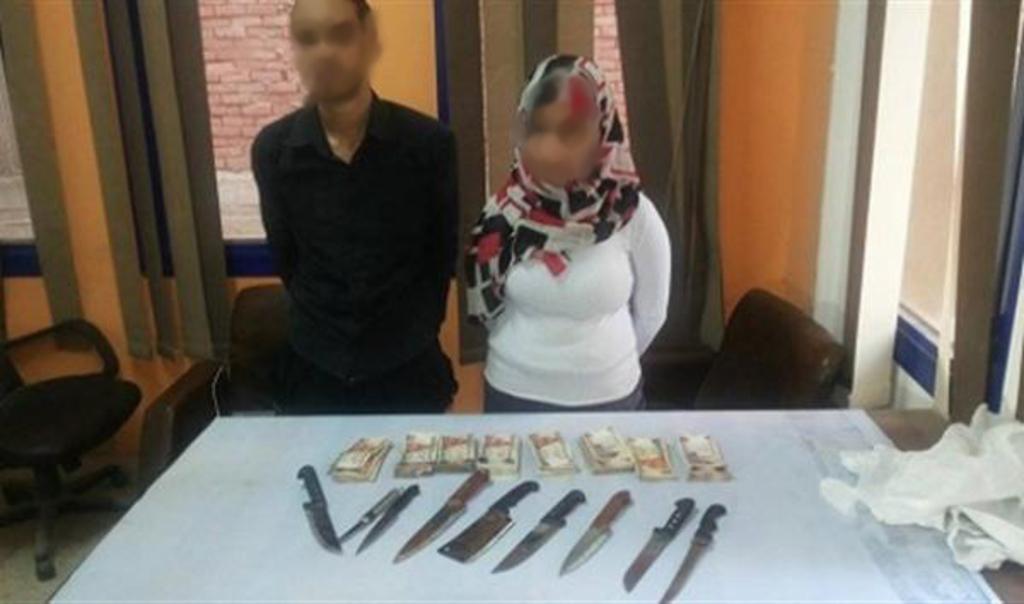Could you give a brief overview of what you see in this image? There is a man and woman stood in front of table on which there are cash and knives and over the backside there are some chairs. Onto the wall there is window and curtains. 